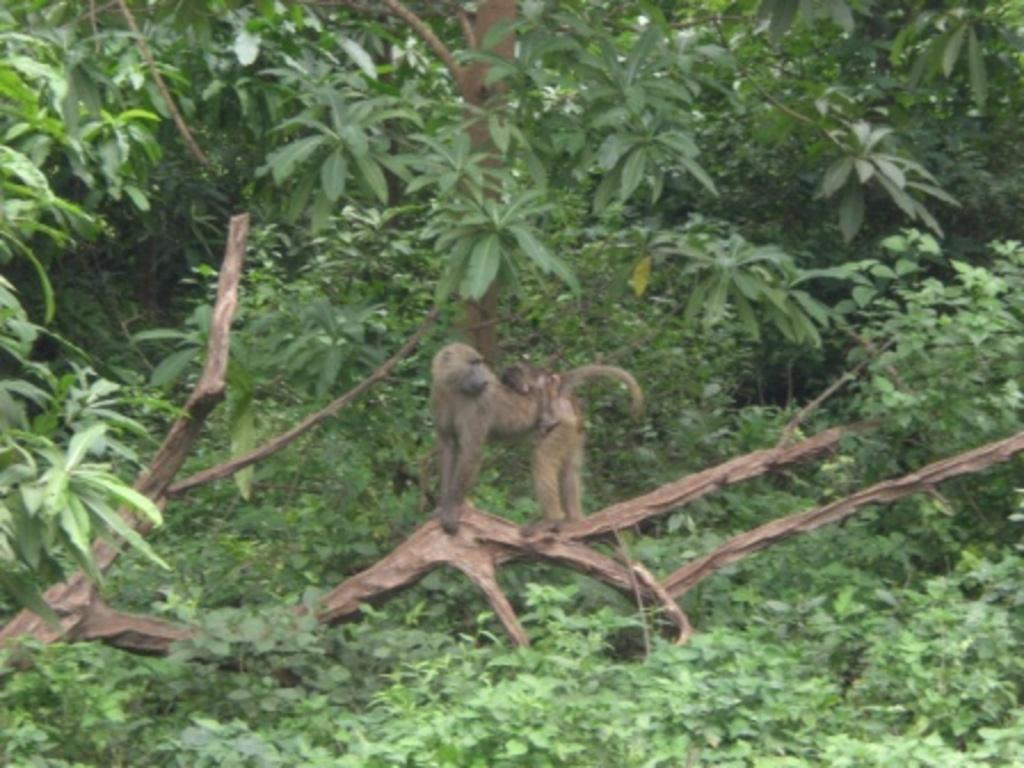What is the main subject of the image? There is an animal standing on a tree branch in the image. Can you describe the relationship between the two animals in the image? There is a smaller animal on the larger animal. What color are the animals in the image? Both animals are brown in color. What can be seen in the background of the image? There are many trees visible in the background of the image. What type of insurance policy is the animal holding in the image? There is no insurance policy present in the image; it features two animals on a tree branch. Can you tell me how many pages are in the notebook that the animal is writing on in the image? There is no notebook present in the image; it features two animals on a tree branch. 